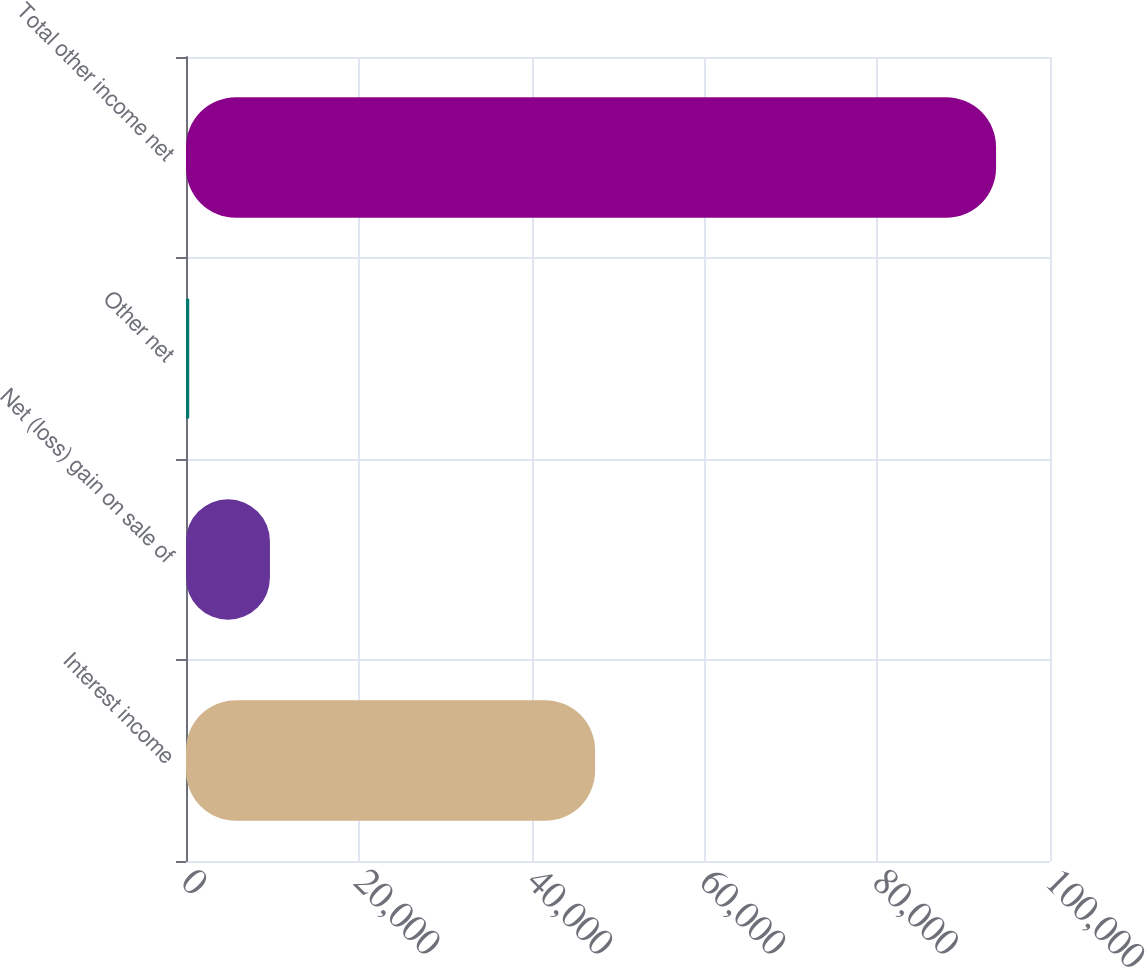Convert chart. <chart><loc_0><loc_0><loc_500><loc_500><bar_chart><fcel>Interest income<fcel>Net (loss) gain on sale of<fcel>Other net<fcel>Total other income net<nl><fcel>47348<fcel>9714.3<fcel>376<fcel>93759<nl></chart> 